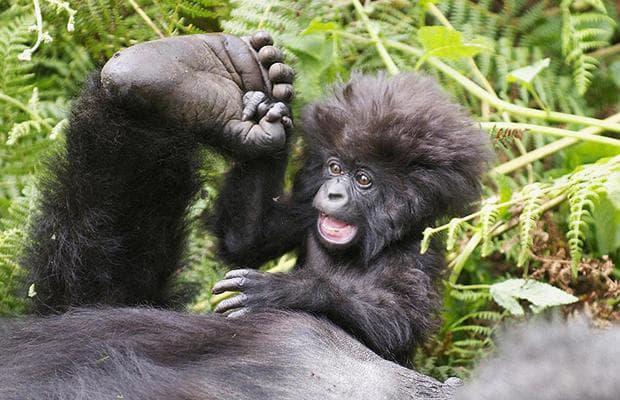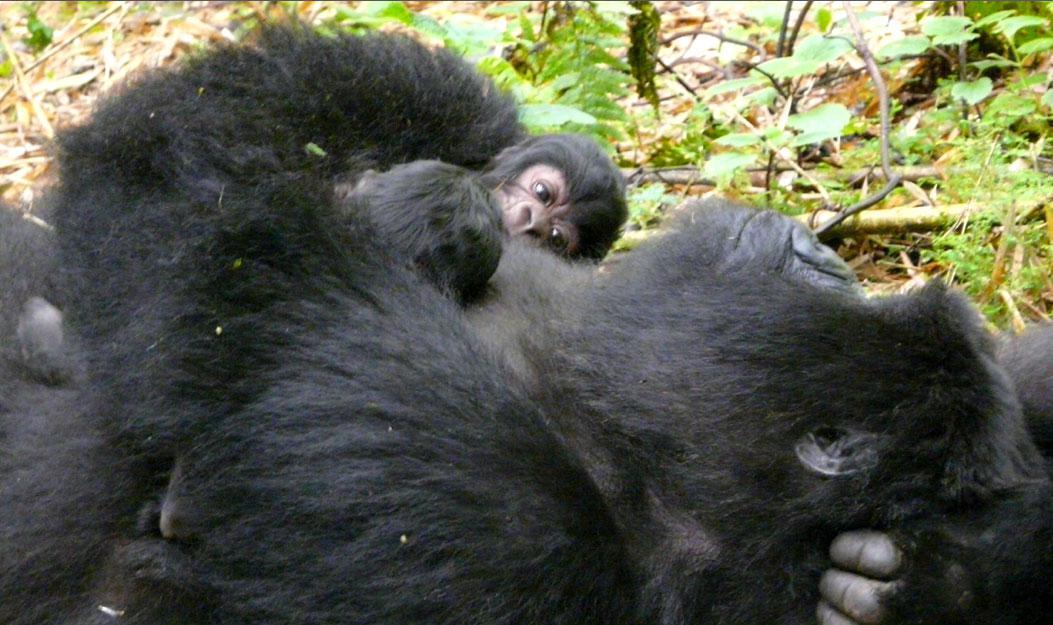The first image is the image on the left, the second image is the image on the right. For the images shown, is this caption "Each image shows an upright adult gorilla with two baby gorillas in front of it, and at least one of the images shows the baby gorillas face-to-face and on the adult gorilla's chest." true? Answer yes or no. No. The first image is the image on the left, the second image is the image on the right. For the images displayed, is the sentence "In each image, two baby gorillas are by their mother." factually correct? Answer yes or no. No. 